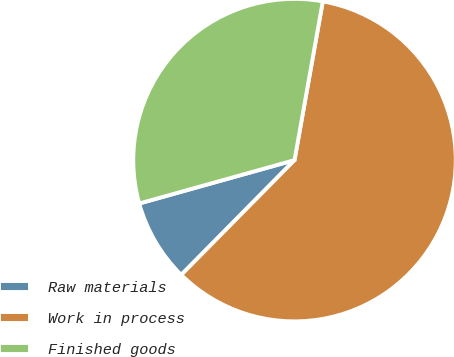Convert chart. <chart><loc_0><loc_0><loc_500><loc_500><pie_chart><fcel>Raw materials<fcel>Work in process<fcel>Finished goods<nl><fcel>8.27%<fcel>59.59%<fcel>32.14%<nl></chart> 